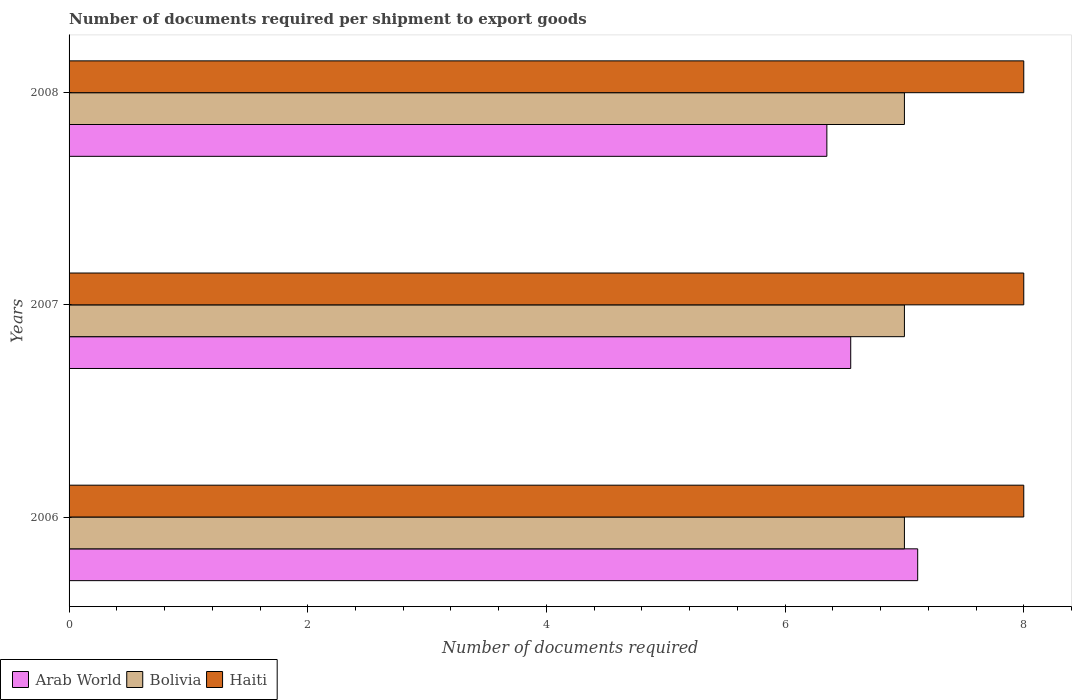How many different coloured bars are there?
Your answer should be very brief. 3. Are the number of bars on each tick of the Y-axis equal?
Make the answer very short. Yes. How many bars are there on the 1st tick from the top?
Offer a very short reply. 3. In how many cases, is the number of bars for a given year not equal to the number of legend labels?
Your answer should be very brief. 0. What is the number of documents required per shipment to export goods in Arab World in 2008?
Give a very brief answer. 6.35. Across all years, what is the maximum number of documents required per shipment to export goods in Arab World?
Your answer should be very brief. 7.11. Across all years, what is the minimum number of documents required per shipment to export goods in Haiti?
Offer a terse response. 8. In which year was the number of documents required per shipment to export goods in Haiti maximum?
Your response must be concise. 2006. In which year was the number of documents required per shipment to export goods in Arab World minimum?
Provide a succinct answer. 2008. What is the total number of documents required per shipment to export goods in Bolivia in the graph?
Provide a succinct answer. 21. What is the difference between the number of documents required per shipment to export goods in Haiti in 2006 and the number of documents required per shipment to export goods in Arab World in 2008?
Ensure brevity in your answer.  1.65. In the year 2006, what is the difference between the number of documents required per shipment to export goods in Haiti and number of documents required per shipment to export goods in Arab World?
Make the answer very short. 0.89. What is the ratio of the number of documents required per shipment to export goods in Bolivia in 2006 to that in 2008?
Offer a terse response. 1. Is the number of documents required per shipment to export goods in Haiti in 2006 less than that in 2008?
Your answer should be compact. No. What is the difference between the highest and the second highest number of documents required per shipment to export goods in Haiti?
Provide a succinct answer. 0. What is the difference between the highest and the lowest number of documents required per shipment to export goods in Bolivia?
Offer a very short reply. 0. In how many years, is the number of documents required per shipment to export goods in Bolivia greater than the average number of documents required per shipment to export goods in Bolivia taken over all years?
Keep it short and to the point. 0. Is the sum of the number of documents required per shipment to export goods in Bolivia in 2006 and 2007 greater than the maximum number of documents required per shipment to export goods in Arab World across all years?
Make the answer very short. Yes. What does the 2nd bar from the top in 2008 represents?
Provide a succinct answer. Bolivia. What does the 3rd bar from the bottom in 2007 represents?
Your answer should be very brief. Haiti. Are all the bars in the graph horizontal?
Provide a short and direct response. Yes. How many years are there in the graph?
Make the answer very short. 3. What is the difference between two consecutive major ticks on the X-axis?
Give a very brief answer. 2. Does the graph contain any zero values?
Offer a very short reply. No. How many legend labels are there?
Offer a terse response. 3. What is the title of the graph?
Provide a short and direct response. Number of documents required per shipment to export goods. Does "St. Martin (French part)" appear as one of the legend labels in the graph?
Offer a very short reply. No. What is the label or title of the X-axis?
Give a very brief answer. Number of documents required. What is the Number of documents required of Arab World in 2006?
Provide a short and direct response. 7.11. What is the Number of documents required of Arab World in 2007?
Keep it short and to the point. 6.55. What is the Number of documents required in Arab World in 2008?
Your answer should be compact. 6.35. What is the Number of documents required in Bolivia in 2008?
Offer a terse response. 7. Across all years, what is the maximum Number of documents required of Arab World?
Offer a terse response. 7.11. Across all years, what is the maximum Number of documents required of Bolivia?
Your answer should be very brief. 7. Across all years, what is the minimum Number of documents required in Arab World?
Make the answer very short. 6.35. Across all years, what is the minimum Number of documents required in Haiti?
Ensure brevity in your answer.  8. What is the total Number of documents required of Arab World in the graph?
Offer a terse response. 20.01. What is the total Number of documents required of Bolivia in the graph?
Keep it short and to the point. 21. What is the difference between the Number of documents required in Arab World in 2006 and that in 2007?
Your response must be concise. 0.56. What is the difference between the Number of documents required in Arab World in 2006 and that in 2008?
Your response must be concise. 0.76. What is the difference between the Number of documents required of Bolivia in 2006 and that in 2008?
Keep it short and to the point. 0. What is the difference between the Number of documents required in Arab World in 2006 and the Number of documents required in Haiti in 2007?
Make the answer very short. -0.89. What is the difference between the Number of documents required in Arab World in 2006 and the Number of documents required in Bolivia in 2008?
Your response must be concise. 0.11. What is the difference between the Number of documents required in Arab World in 2006 and the Number of documents required in Haiti in 2008?
Keep it short and to the point. -0.89. What is the difference between the Number of documents required of Arab World in 2007 and the Number of documents required of Bolivia in 2008?
Provide a short and direct response. -0.45. What is the difference between the Number of documents required of Arab World in 2007 and the Number of documents required of Haiti in 2008?
Provide a succinct answer. -1.45. What is the average Number of documents required in Arab World per year?
Ensure brevity in your answer.  6.67. What is the average Number of documents required in Bolivia per year?
Your answer should be very brief. 7. In the year 2006, what is the difference between the Number of documents required in Arab World and Number of documents required in Bolivia?
Your response must be concise. 0.11. In the year 2006, what is the difference between the Number of documents required in Arab World and Number of documents required in Haiti?
Make the answer very short. -0.89. In the year 2006, what is the difference between the Number of documents required in Bolivia and Number of documents required in Haiti?
Provide a succinct answer. -1. In the year 2007, what is the difference between the Number of documents required of Arab World and Number of documents required of Bolivia?
Your response must be concise. -0.45. In the year 2007, what is the difference between the Number of documents required of Arab World and Number of documents required of Haiti?
Offer a very short reply. -1.45. In the year 2007, what is the difference between the Number of documents required of Bolivia and Number of documents required of Haiti?
Provide a short and direct response. -1. In the year 2008, what is the difference between the Number of documents required in Arab World and Number of documents required in Bolivia?
Your answer should be compact. -0.65. In the year 2008, what is the difference between the Number of documents required of Arab World and Number of documents required of Haiti?
Make the answer very short. -1.65. In the year 2008, what is the difference between the Number of documents required of Bolivia and Number of documents required of Haiti?
Ensure brevity in your answer.  -1. What is the ratio of the Number of documents required in Arab World in 2006 to that in 2007?
Your response must be concise. 1.09. What is the ratio of the Number of documents required in Bolivia in 2006 to that in 2007?
Provide a succinct answer. 1. What is the ratio of the Number of documents required in Arab World in 2006 to that in 2008?
Give a very brief answer. 1.12. What is the ratio of the Number of documents required of Haiti in 2006 to that in 2008?
Your answer should be compact. 1. What is the ratio of the Number of documents required in Arab World in 2007 to that in 2008?
Your response must be concise. 1.03. What is the difference between the highest and the second highest Number of documents required in Arab World?
Ensure brevity in your answer.  0.56. What is the difference between the highest and the second highest Number of documents required of Bolivia?
Your answer should be very brief. 0. What is the difference between the highest and the second highest Number of documents required of Haiti?
Provide a succinct answer. 0. What is the difference between the highest and the lowest Number of documents required of Arab World?
Your answer should be very brief. 0.76. What is the difference between the highest and the lowest Number of documents required of Bolivia?
Your answer should be compact. 0. 